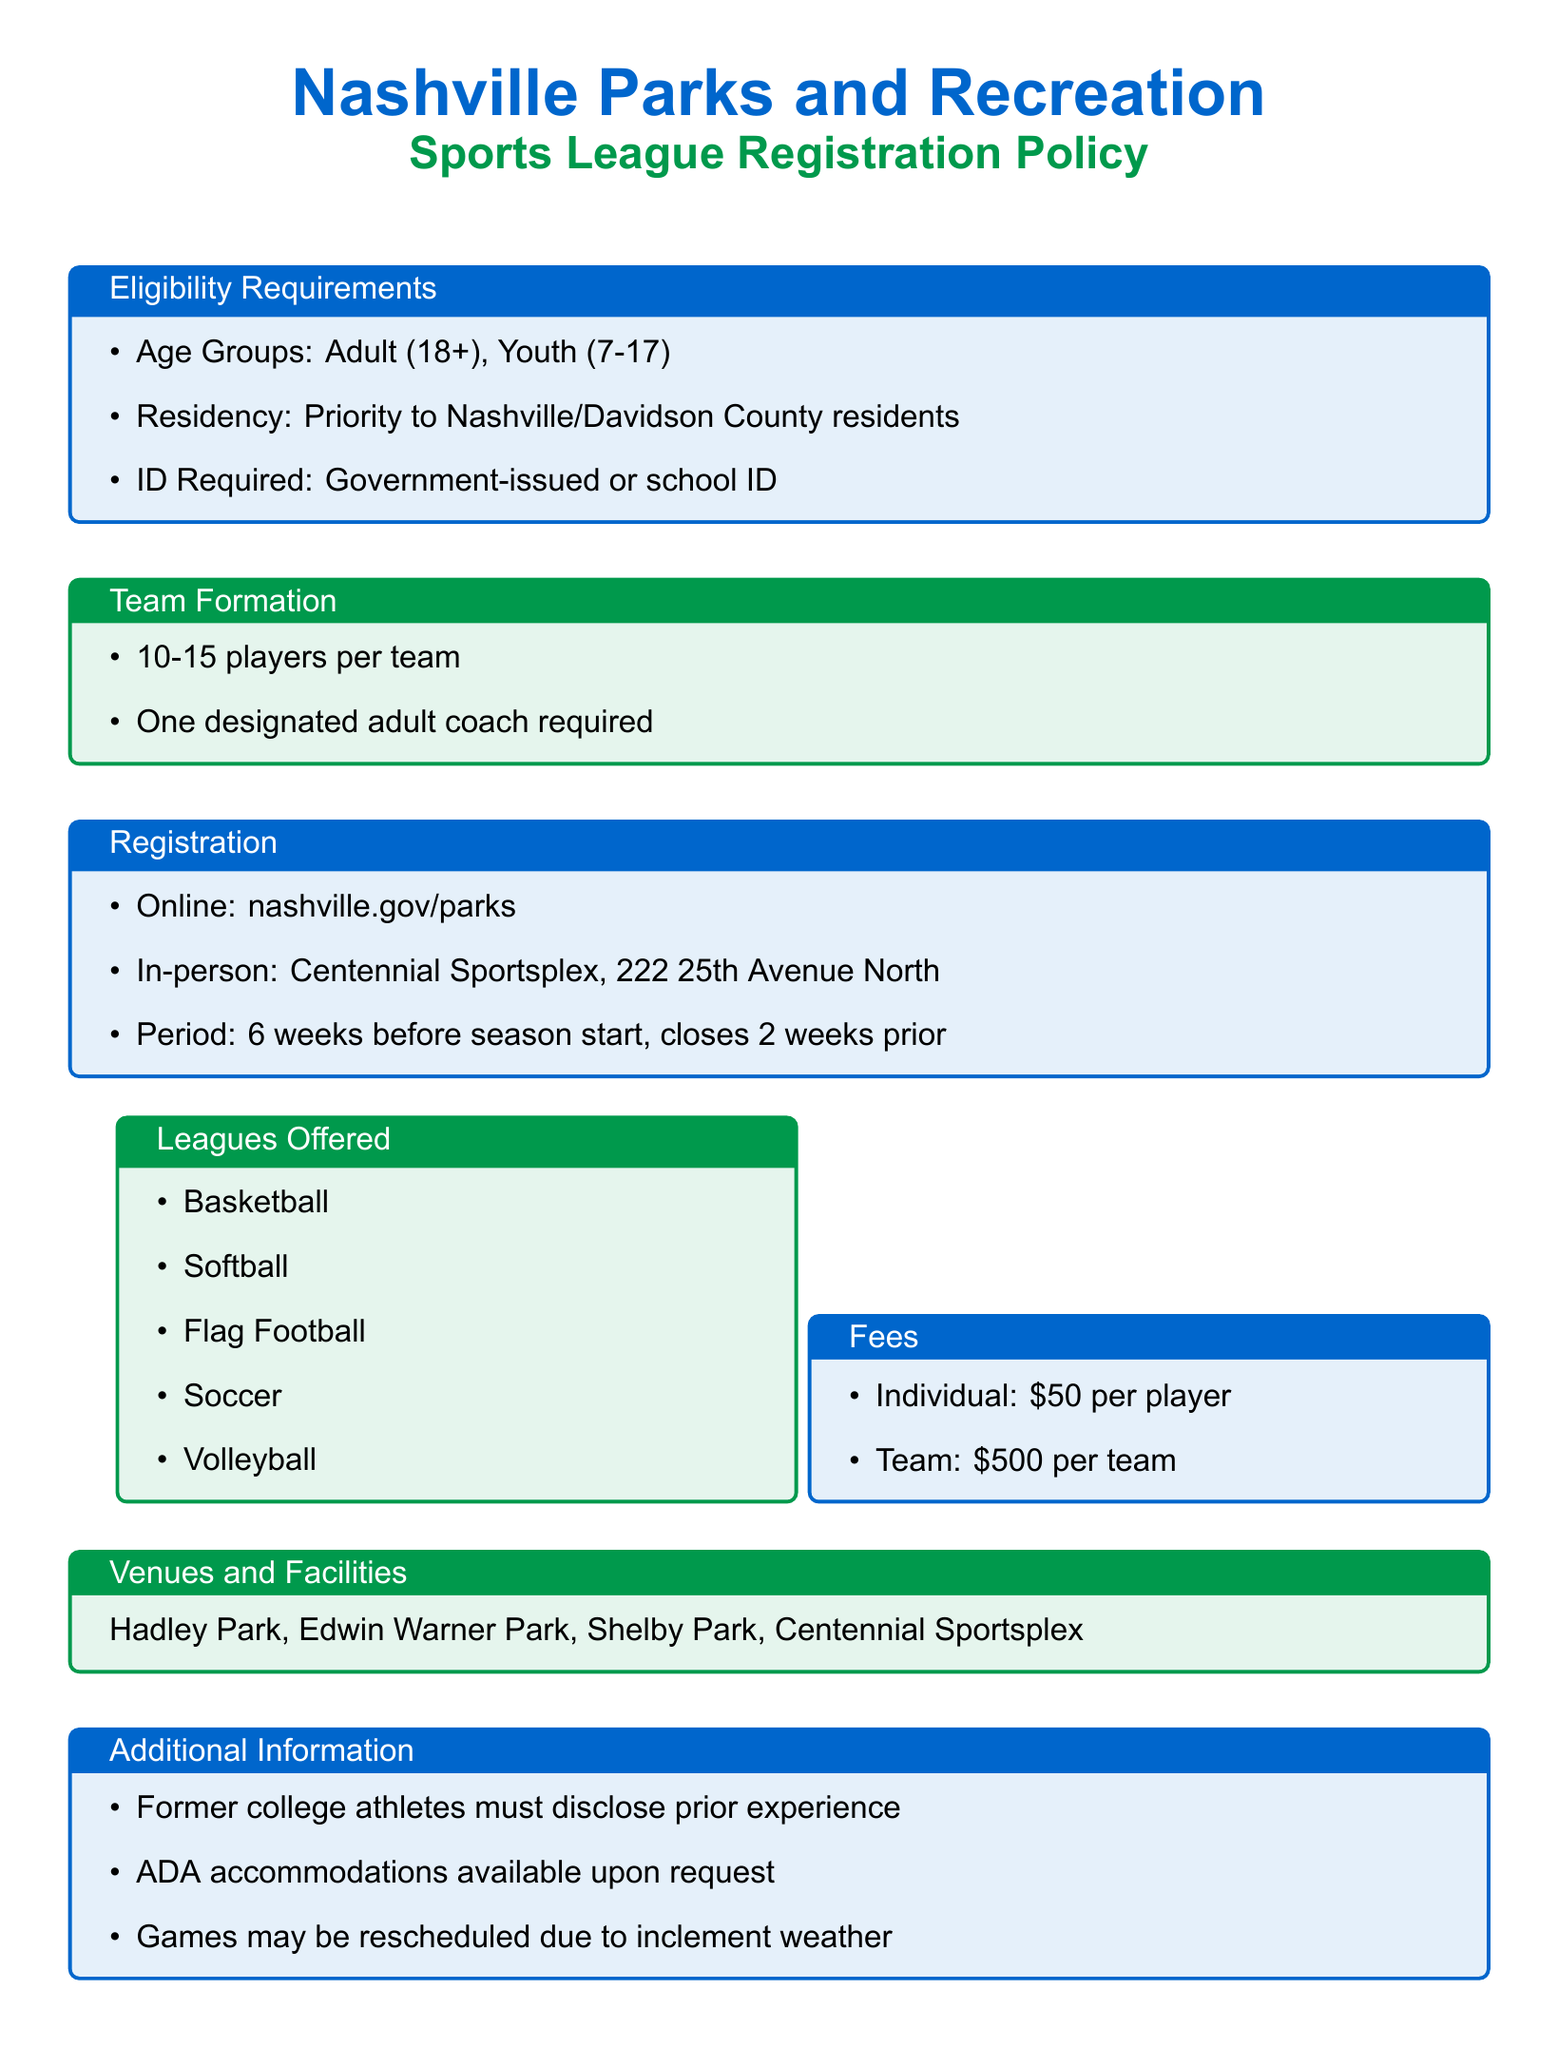What age groups are eligible for the sports leagues? The eligibility requirements specify that there are two age groups: Adult (18+) and Youth (7-17).
Answer: Adult (18+), Youth (7-17) What is the registration period for the sports leagues? According to the document, registration opens 6 weeks before the season starts and closes 2 weeks prior.
Answer: 6 weeks before season start, closes 2 weeks prior Where can one register for the sports leagues? The document states that registration is available online at nashville.gov/parks and in-person at Centennial Sportsplex.
Answer: nashville.gov/parks, Centennial Sportsplex What is the fee for an individual player? The fees section indicates that the cost for an individual player is $50.
Answer: $50 How many players are required per team? The team formation guidelines specify that each team should have between 10 to 15 players.
Answer: 10-15 players What additional information must former college athletes provide? The document mentions that former college athletes must disclose their prior experience when registering.
Answer: Prior experience What accommodations are available upon request? The additional information section notes that ADA accommodations are available upon request.
Answer: ADA accommodations How many leagues are offered according to the document? The leagues offered section lists five sports leagues available for registration.
Answer: Five leagues What is the team fee for joining a sports league? The fees section provides that the team fee is $500.
Answer: $500 